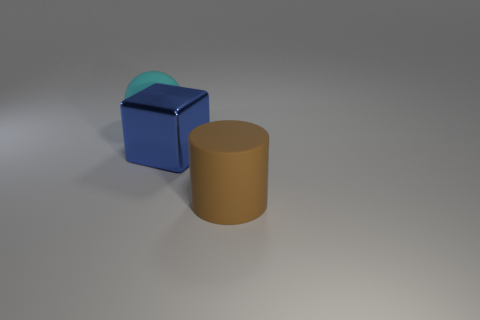Subtract all purple balls. Subtract all yellow cylinders. How many balls are left? 1 Add 1 big red cylinders. How many objects exist? 4 Subtract all blocks. How many objects are left? 2 Subtract all cyan rubber spheres. Subtract all big cyan spheres. How many objects are left? 1 Add 2 rubber cylinders. How many rubber cylinders are left? 3 Add 2 large red rubber things. How many large red rubber things exist? 2 Subtract 0 gray cubes. How many objects are left? 3 